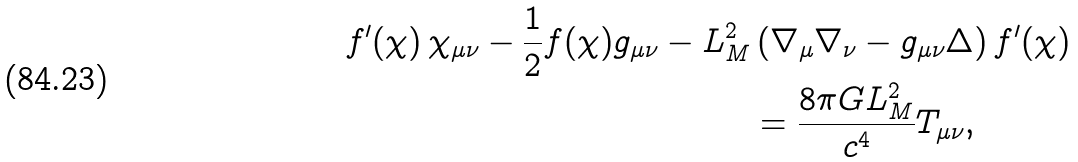<formula> <loc_0><loc_0><loc_500><loc_500>f ^ { \prime } ( \chi ) \, \chi _ { \mu \nu } - \frac { 1 } { 2 } f ( \chi ) g _ { \mu \nu } - L _ { M } ^ { 2 } & \left ( \nabla _ { \mu } \nabla _ { \nu } - g _ { \mu \nu } \Delta \right ) f ^ { \prime } ( \chi ) \\ & = \frac { 8 \pi G L _ { M } ^ { 2 } } { c ^ { 4 } } T _ { \mu \nu } ,</formula> 